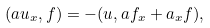Convert formula to latex. <formula><loc_0><loc_0><loc_500><loc_500>( a u _ { x } , f ) = - ( u , a f _ { x } + a _ { x } f ) ,</formula> 